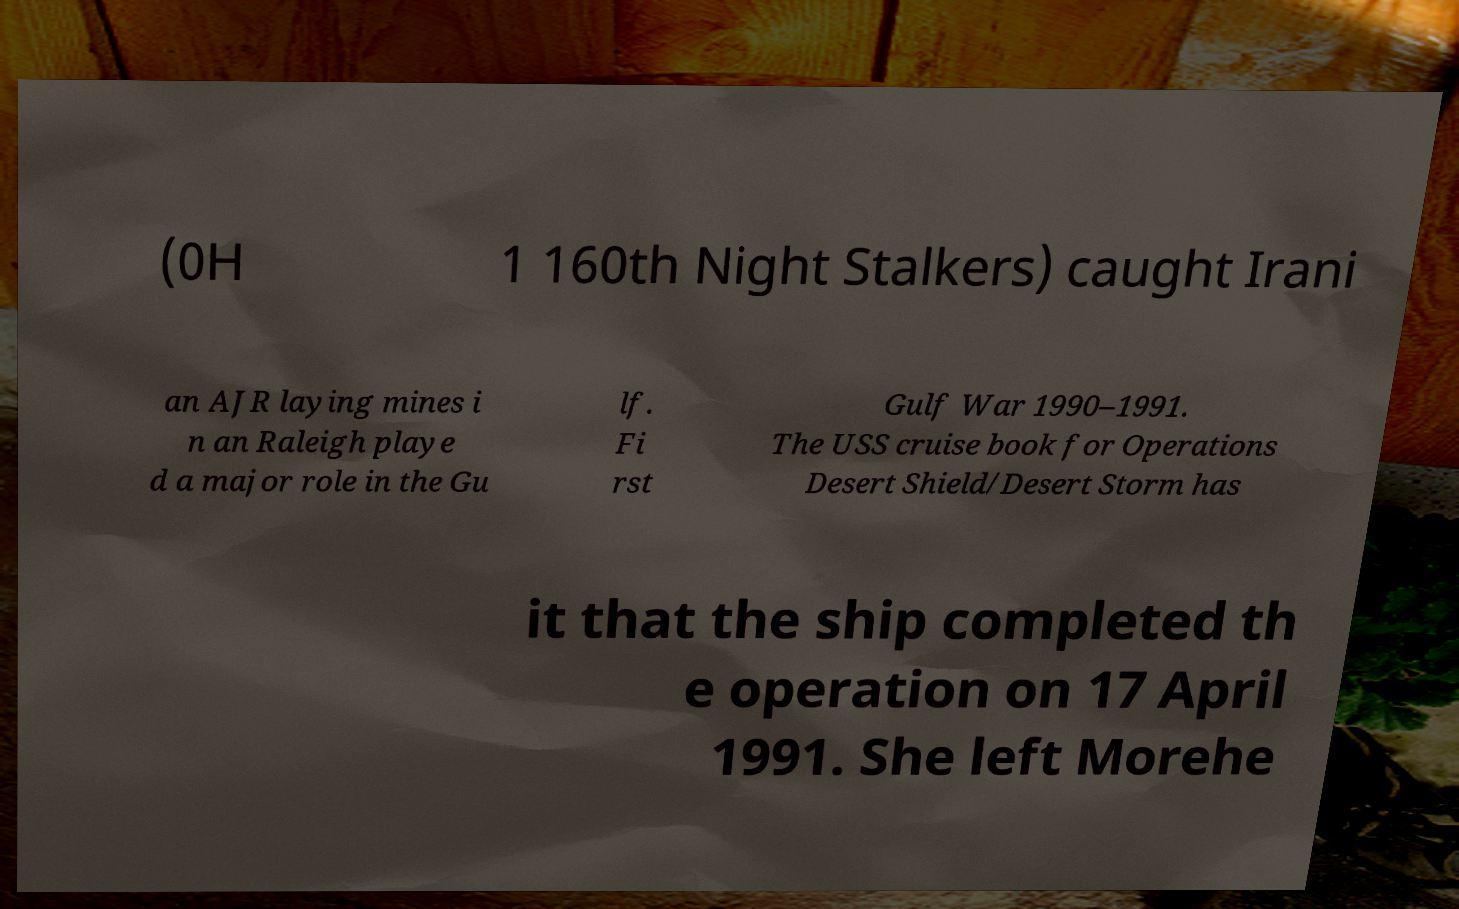There's text embedded in this image that I need extracted. Can you transcribe it verbatim? (0H 1 160th Night Stalkers) caught Irani an AJR laying mines i n an Raleigh playe d a major role in the Gu lf. Fi rst Gulf War 1990–1991. The USS cruise book for Operations Desert Shield/Desert Storm has it that the ship completed th e operation on 17 April 1991. She left Morehe 